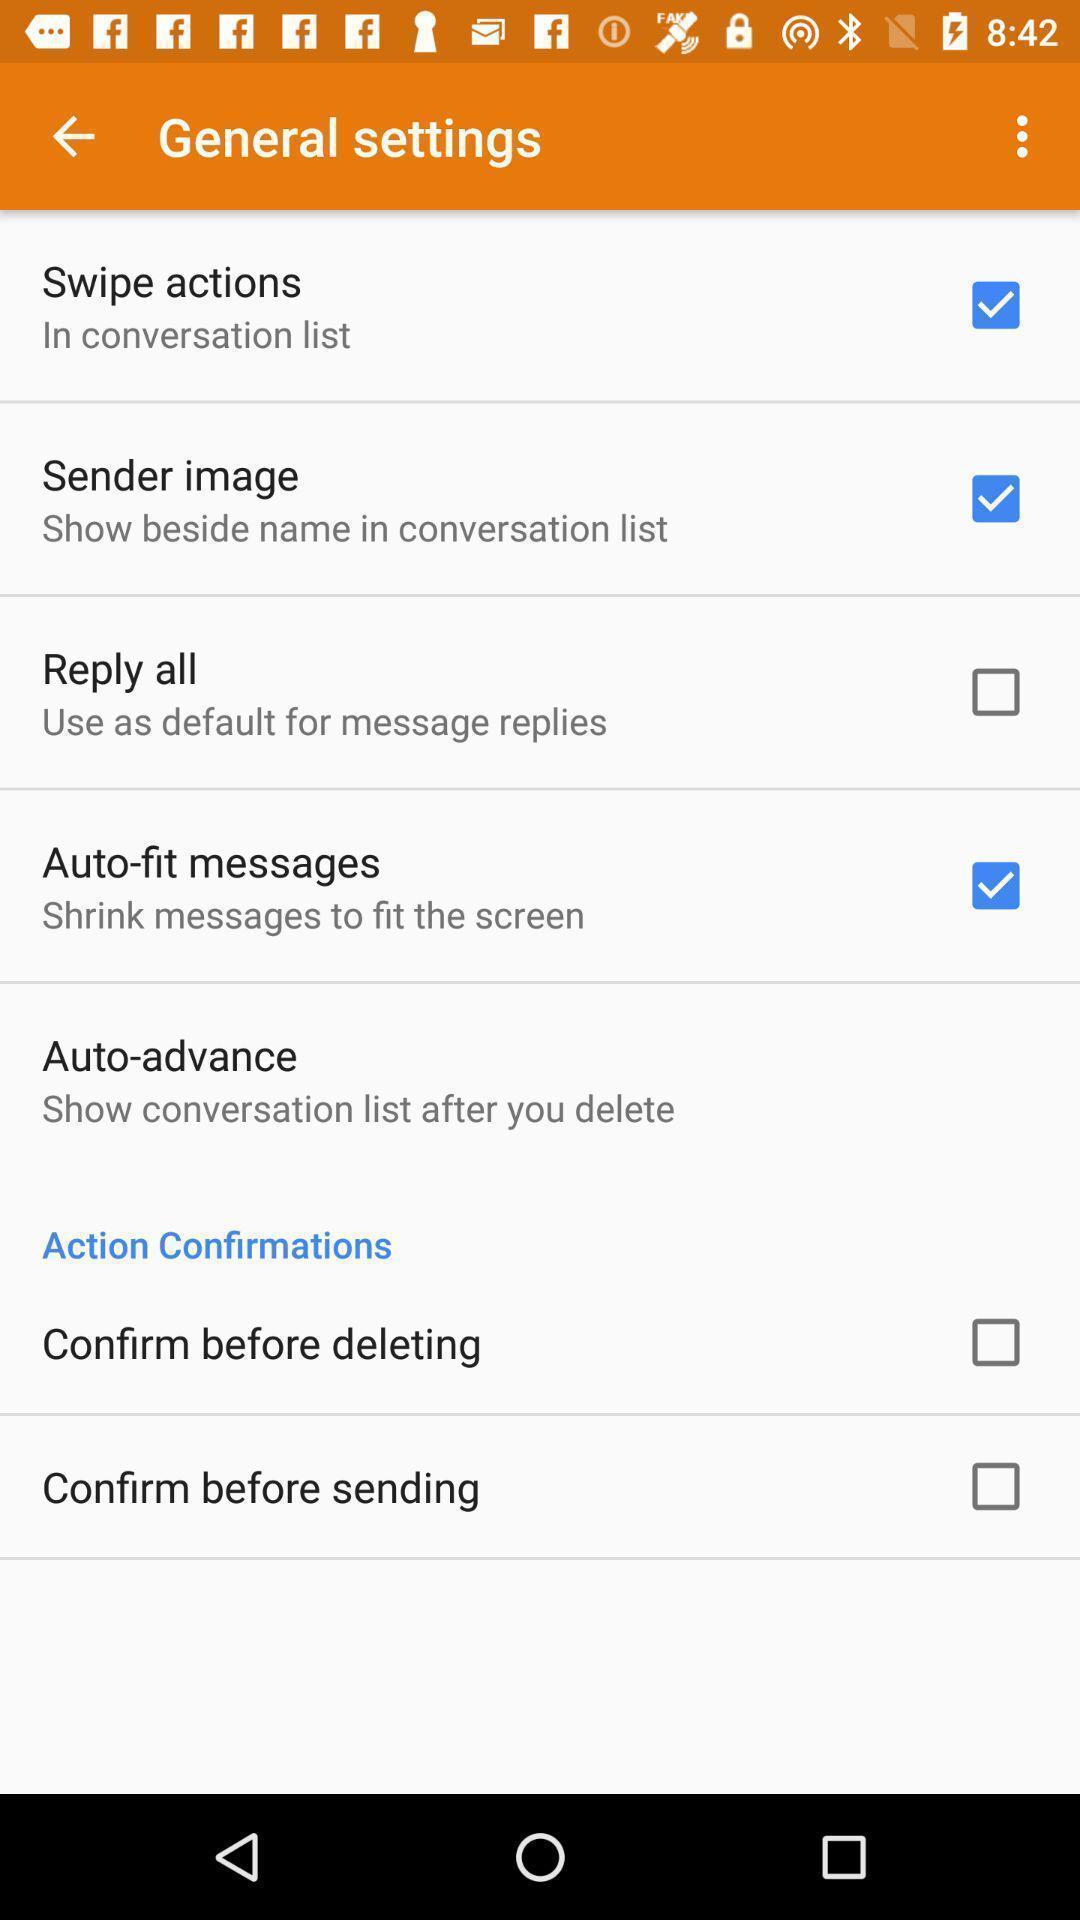Describe the content in this image. Screen shows settings page. 